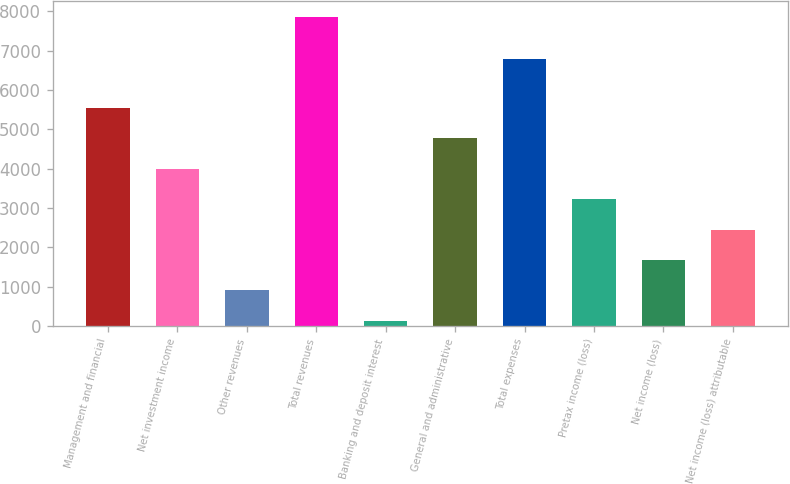<chart> <loc_0><loc_0><loc_500><loc_500><bar_chart><fcel>Management and financial<fcel>Net investment income<fcel>Other revenues<fcel>Total revenues<fcel>Banking and deposit interest<fcel>General and administrative<fcel>Total expenses<fcel>Pretax income (loss)<fcel>Net income (loss)<fcel>Net income (loss) attributable<nl><fcel>5546<fcel>4000<fcel>908<fcel>7865<fcel>135<fcel>4773<fcel>6780<fcel>3227<fcel>1681<fcel>2454<nl></chart> 